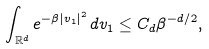<formula> <loc_0><loc_0><loc_500><loc_500>\int _ { \mathbb { R } ^ { d } } e ^ { - \beta | v _ { 1 } | ^ { 2 } } \, d v _ { 1 } \leq C _ { d } \beta ^ { - d / 2 } ,</formula> 